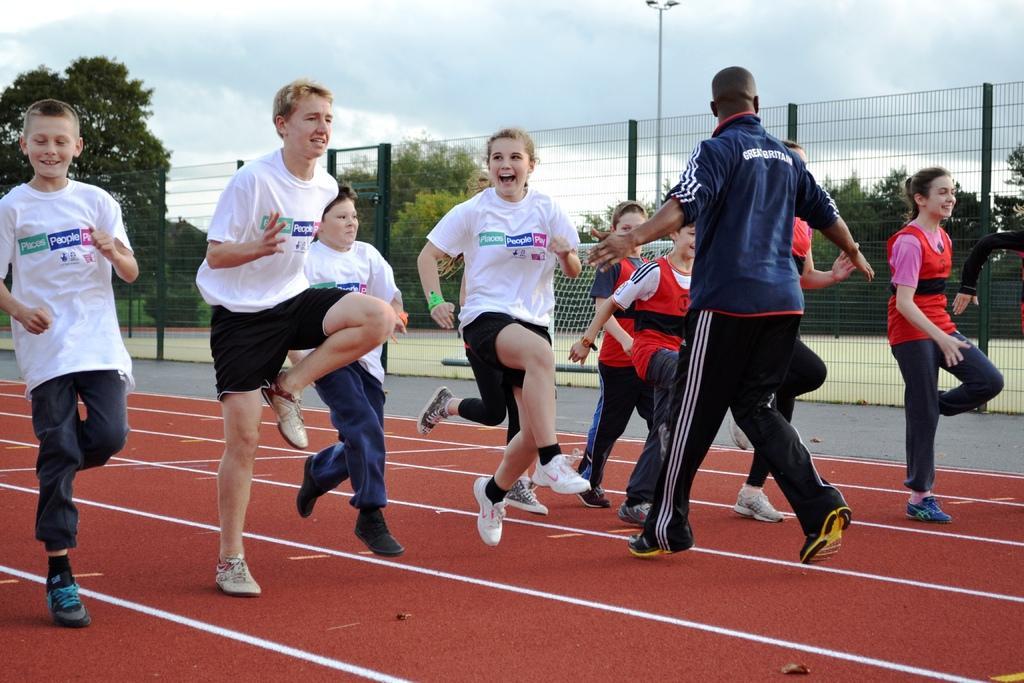In one or two sentences, can you explain what this image depicts? In this image in the middle, there is a woman, she wears a t shirt, trouser, shoes, she is running, behind her there is a boy, he wears a t shirt, trouser, shoes, he is running. On the left there is a boy, he wears a t shirt, trouser, shoes, he is running and there is a boy, he wears a t shirt, trouser, shoes, he is running. On the right there is a girl, she wears a t shirt, trouser, shoes, she is running, behind her there are people, they are running. In the middle there is a man, he wears a t shirt, trouser, shoes, he is running. In the background there are trees, fence, grass, sky and clouds. 